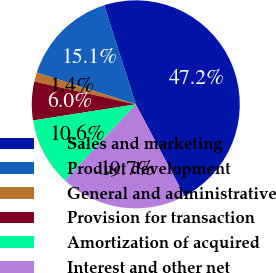Convert chart. <chart><loc_0><loc_0><loc_500><loc_500><pie_chart><fcel>Sales and marketing<fcel>Product development<fcel>General and administrative<fcel>Provision for transaction<fcel>Amortization of acquired<fcel>Interest and other net<nl><fcel>47.15%<fcel>15.14%<fcel>1.42%<fcel>6.0%<fcel>10.57%<fcel>19.72%<nl></chart> 